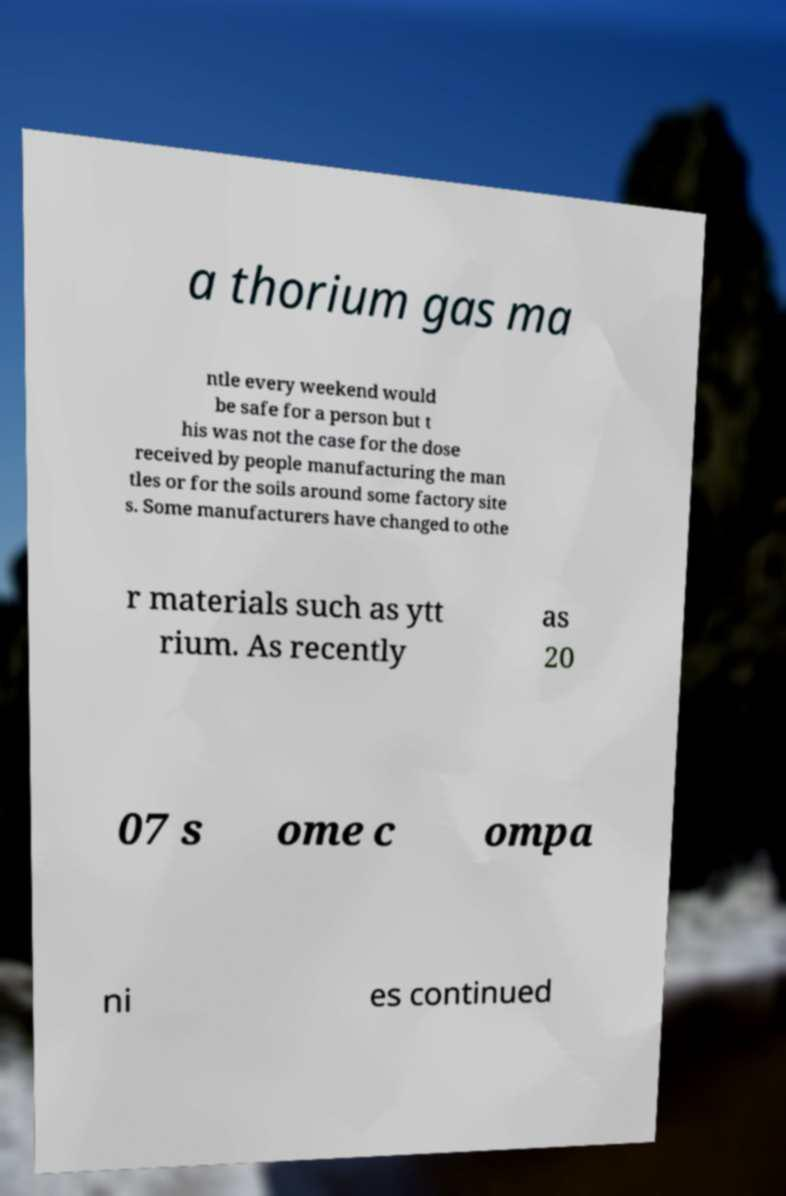I need the written content from this picture converted into text. Can you do that? a thorium gas ma ntle every weekend would be safe for a person but t his was not the case for the dose received by people manufacturing the man tles or for the soils around some factory site s. Some manufacturers have changed to othe r materials such as ytt rium. As recently as 20 07 s ome c ompa ni es continued 